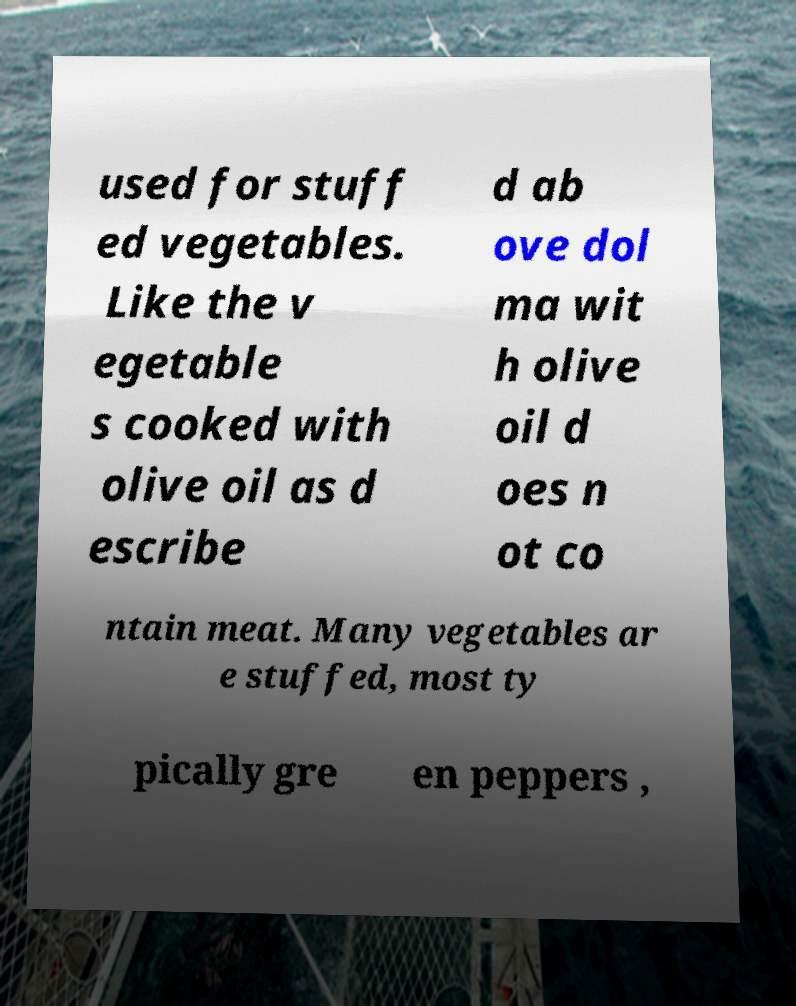Could you assist in decoding the text presented in this image and type it out clearly? used for stuff ed vegetables. Like the v egetable s cooked with olive oil as d escribe d ab ove dol ma wit h olive oil d oes n ot co ntain meat. Many vegetables ar e stuffed, most ty pically gre en peppers , 